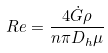<formula> <loc_0><loc_0><loc_500><loc_500>R e = \frac { 4 \dot { G } \rho } { n \pi D _ { h } \mu }</formula> 